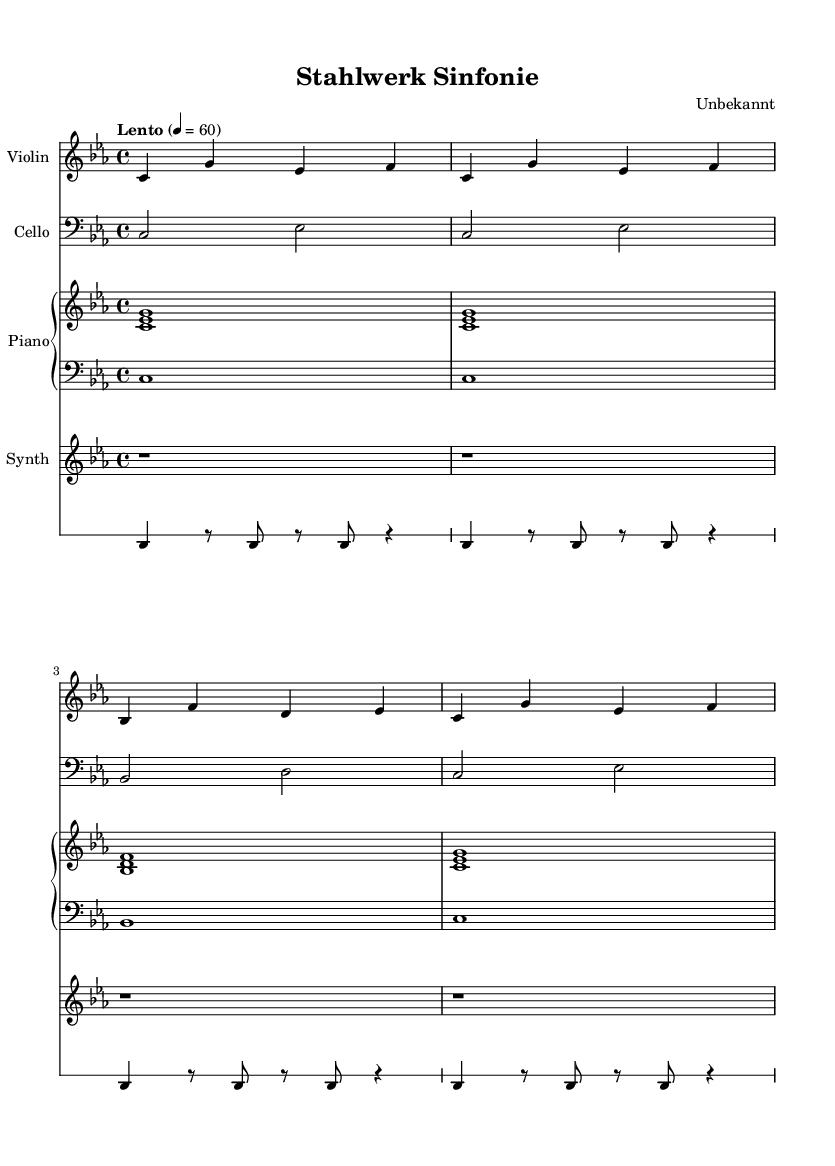what is the key signature of this music? The key signature is C minor, indicated by three flats shown at the beginning of the piece.
Answer: C minor what is the time signature of this piece? The time signature is 4/4, which is indicated by the time signature marking at the beginning of the score.
Answer: 4/4 what is the tempo of the composition? The tempo marking shows "Lento," which instructs the performers to play slowly, and the metronome marking is 60 beats per minute.
Answer: Lento how many measures are in the violin part? The violin part consists of four measures, as indicated by the grouping of notes and the vertical bar lines separating each measure.
Answer: 4 which instrument plays a drum pattern? The industrial section includes a drum pattern, specifically played by the drums, which is indicated by the indication of a "DrumStaff."
Answer: Drums what is the role of the synth in this composition? The synth part is notated with whole rests throughout the piece, indicating it is silent or inactive during the duration depicted.
Answer: Silent how does the cello contribute to the overall sound? The cello reinforces the harmonic foundation by playing sustained notes and helping to create a somber, stable sound characteristic of minimalism.
Answer: Harmonic foundation 